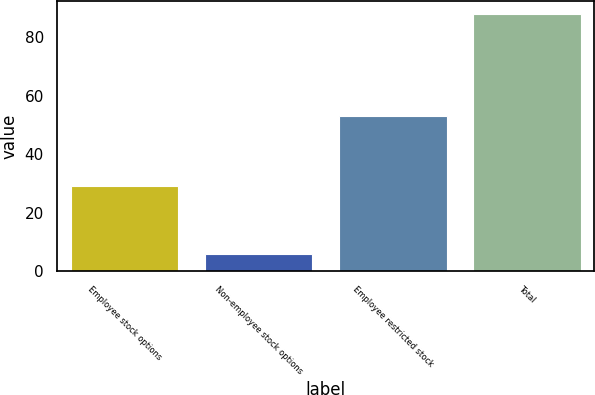Convert chart to OTSL. <chart><loc_0><loc_0><loc_500><loc_500><bar_chart><fcel>Employee stock options<fcel>Non-employee stock options<fcel>Employee restricted stock<fcel>Total<nl><fcel>29<fcel>6<fcel>53<fcel>88<nl></chart> 